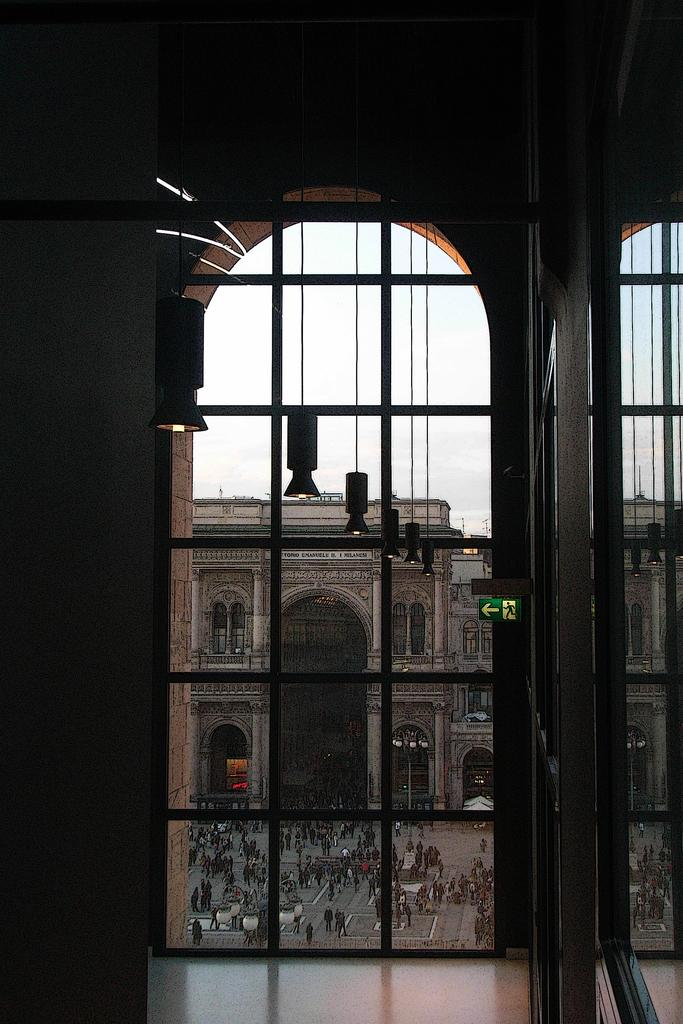What type of structures can be seen in the image? There are buildings in the image. What is attached to the buildings or nearby structures? A sign board, railings, and pillars are present in the image. What is happening on the road in the image? There are persons on the road in the image. What other objects can be seen on the road or nearby? A street pole and street lights are visible in the image. What is visible in the sky in the image? The sky is visible in the image, and clouds are present in the sky. What type of humor can be seen in the image? There is no humor present in the image; it is a scene of buildings, structures, and people on the road. Can you see a tramp in the image? There is no tramp present in the image. What type of screw is used to attach the street lights to the street pole? The image does not provide information about the type of screw used to attach the street lights to the street pole. 